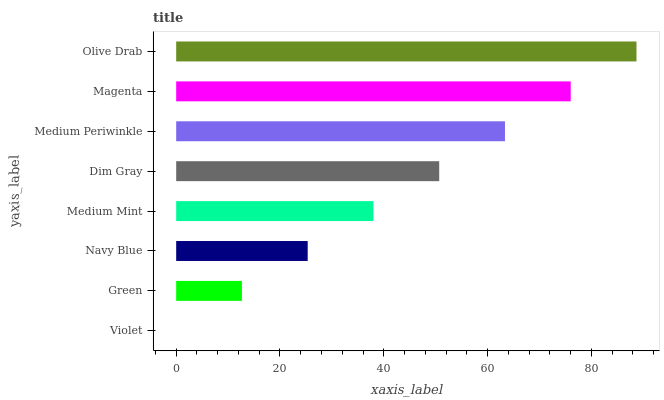Is Violet the minimum?
Answer yes or no. Yes. Is Olive Drab the maximum?
Answer yes or no. Yes. Is Green the minimum?
Answer yes or no. No. Is Green the maximum?
Answer yes or no. No. Is Green greater than Violet?
Answer yes or no. Yes. Is Violet less than Green?
Answer yes or no. Yes. Is Violet greater than Green?
Answer yes or no. No. Is Green less than Violet?
Answer yes or no. No. Is Dim Gray the high median?
Answer yes or no. Yes. Is Medium Mint the low median?
Answer yes or no. Yes. Is Medium Periwinkle the high median?
Answer yes or no. No. Is Violet the low median?
Answer yes or no. No. 